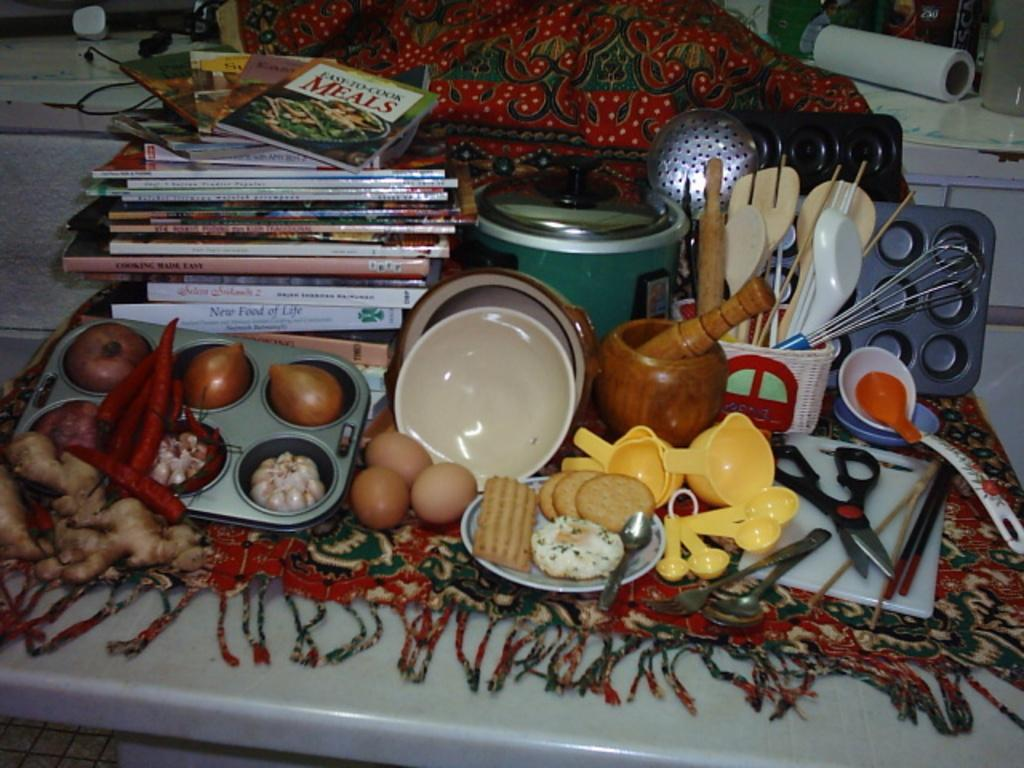<image>
Give a short and clear explanation of the subsequent image. Easy to Cook Meals is the title of the book on the top of the pile. 